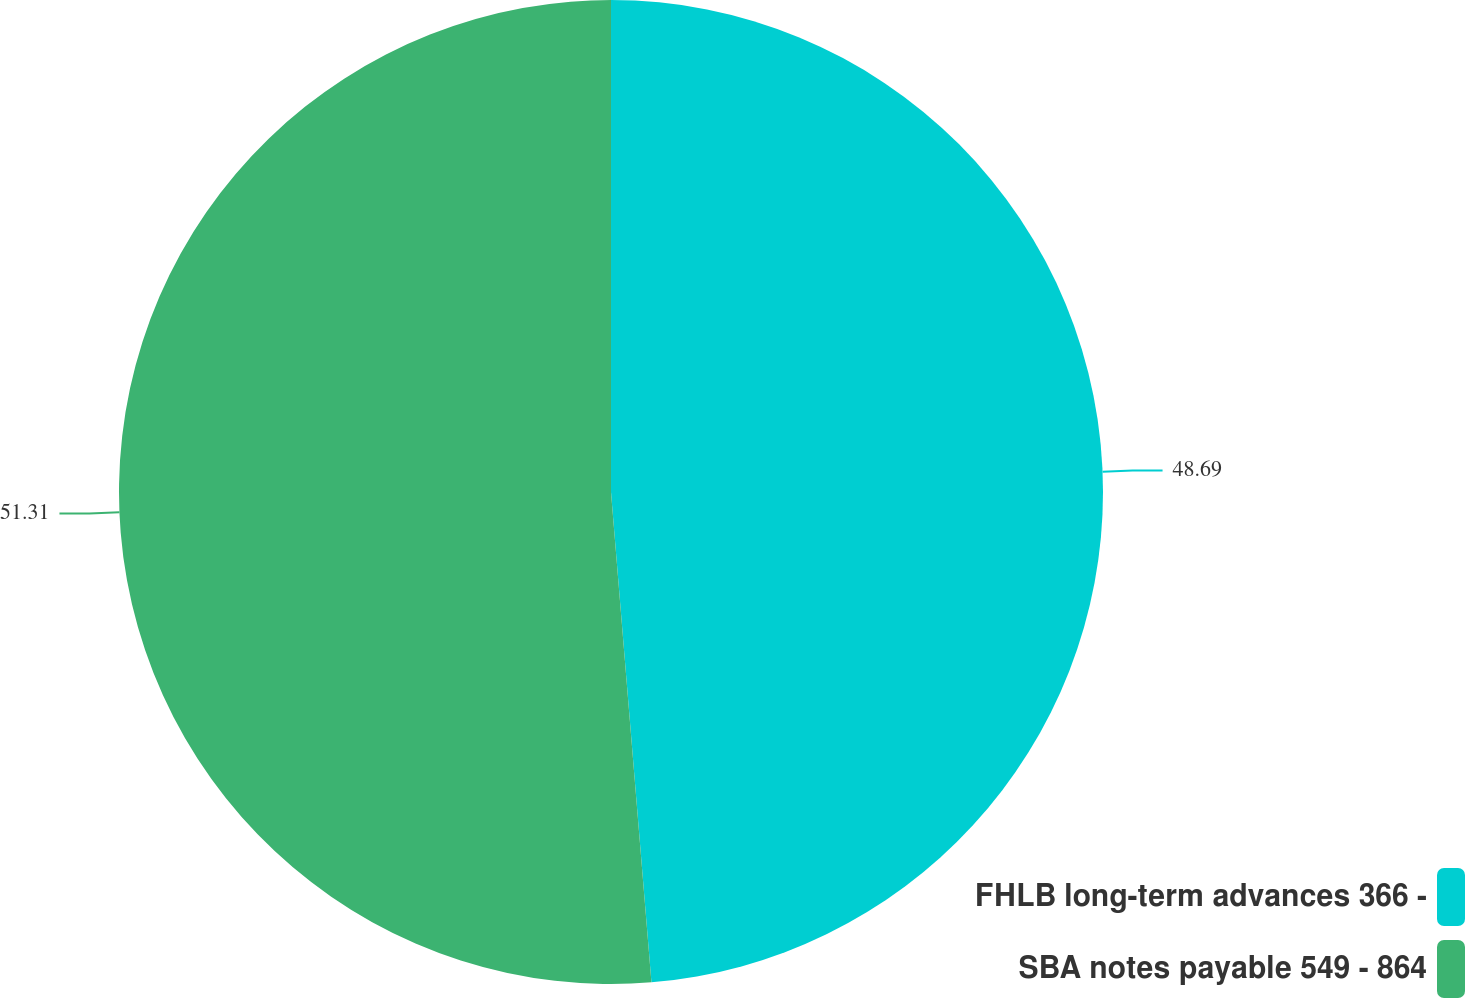<chart> <loc_0><loc_0><loc_500><loc_500><pie_chart><fcel>FHLB long-term advances 366 -<fcel>SBA notes payable 549 - 864<nl><fcel>48.69%<fcel>51.31%<nl></chart> 